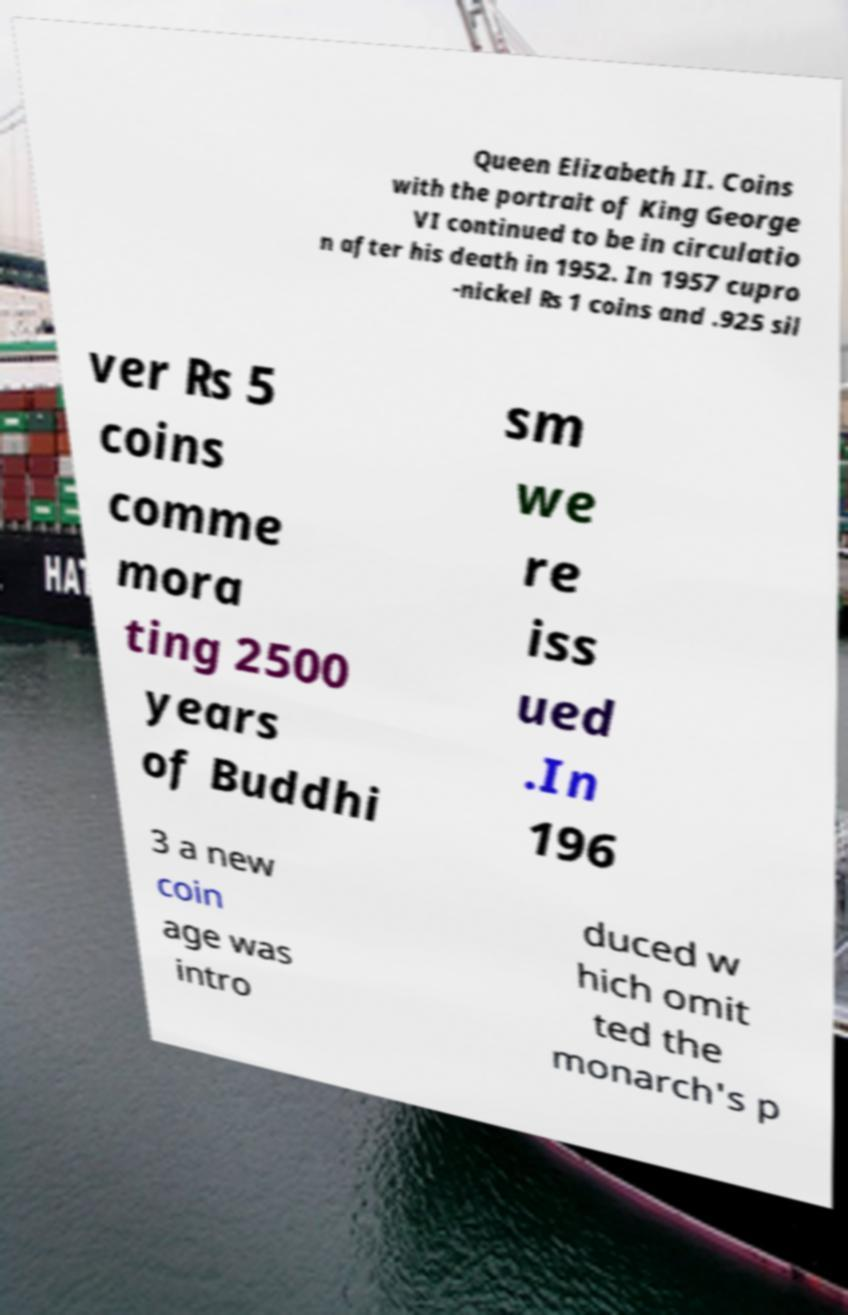I need the written content from this picture converted into text. Can you do that? Queen Elizabeth II. Coins with the portrait of King George VI continued to be in circulatio n after his death in 1952. In 1957 cupro -nickel ₨ 1 coins and .925 sil ver ₨ 5 coins comme mora ting 2500 years of Buddhi sm we re iss ued .In 196 3 a new coin age was intro duced w hich omit ted the monarch's p 